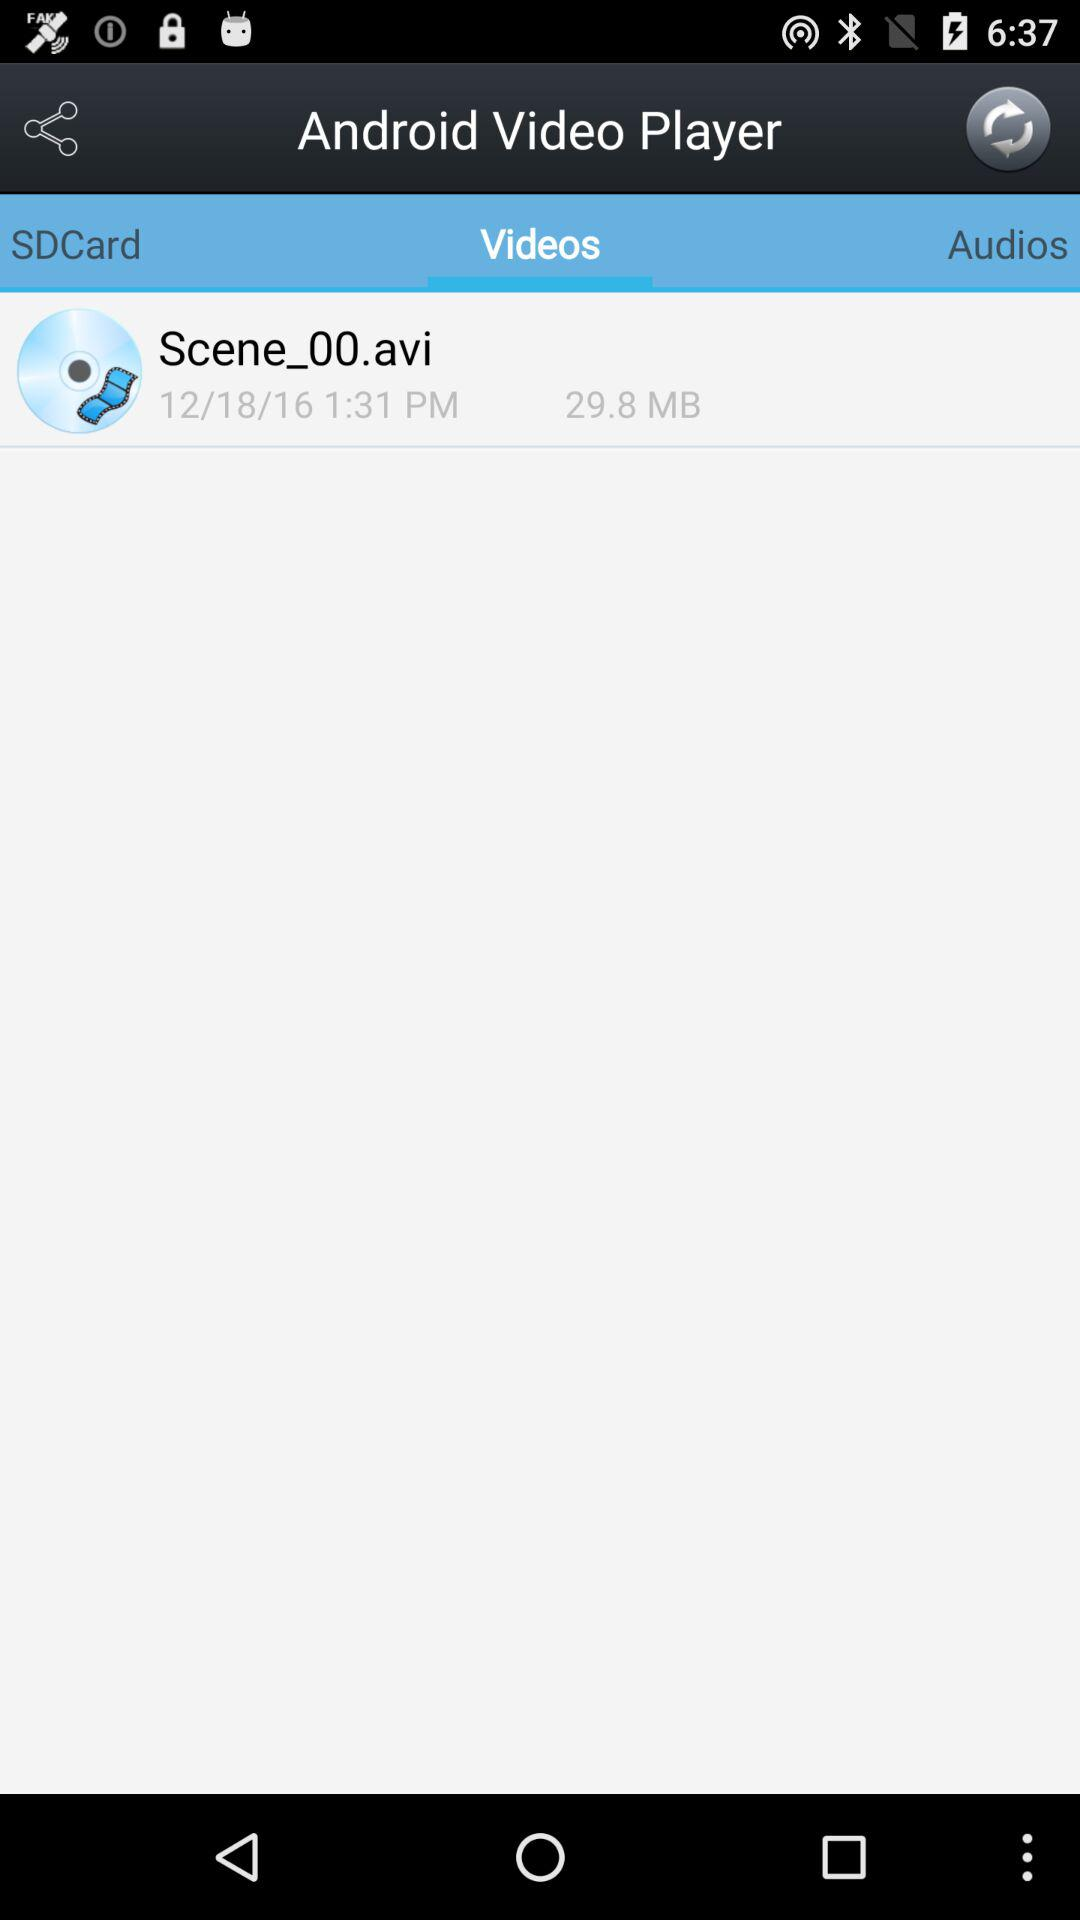What is the given date? The given date is December 18, 2016. 